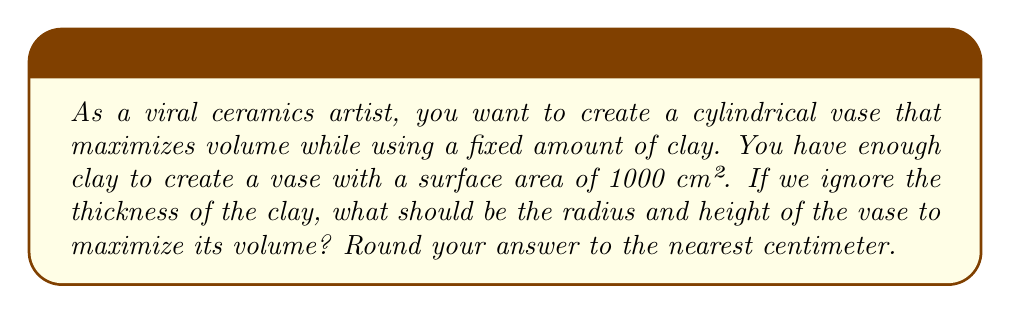Can you solve this math problem? Let's approach this step-by-step:

1) For a cylindrical vase, we have:
   - Radius: $r$
   - Height: $h$
   - Surface area: $S = 2\pi r^2 + 2\pi rh = 1000$ cm²
   - Volume: $V = \pi r^2h$

2) We need to express $h$ in terms of $r$ using the surface area equation:

   $$2\pi r^2 + 2\pi rh = 1000$$
   $$2\pi rh = 1000 - 2\pi r^2$$
   $$h = \frac{500}{\pi r} - r$$

3) Now, we can express the volume in terms of $r$ only:

   $$V = \pi r^2h = \pi r^2(\frac{500}{\pi r} - r) = 500r - \pi r^3$$

4) To find the maximum volume, we need to differentiate $V$ with respect to $r$ and set it to zero:

   $$\frac{dV}{dr} = 500 - 3\pi r^2 = 0$$

5) Solving this equation:

   $$500 = 3\pi r^2$$
   $$r^2 = \frac{500}{3\pi}$$
   $$r = \sqrt{\frac{500}{3\pi}} \approx 7.29$$

6) To find $h$, we substitute this value of $r$ back into the equation from step 2:

   $$h = \frac{500}{\pi r} - r \approx 14.58$$

7) Rounding to the nearest centimeter:
   $r \approx 7$ cm
   $h \approx 15$ cm

8) We can verify that these dimensions give a surface area close to 1000 cm²:

   $$S = 2\pi r^2 + 2\pi rh \approx 2\pi(7^2) + 2\pi(7)(15) \approx 968 + 659 = 1027$$ cm²

   This is close enough considering our rounding.
Answer: The optimal dimensions for the vase are approximately 7 cm for the radius and 15 cm for the height. 